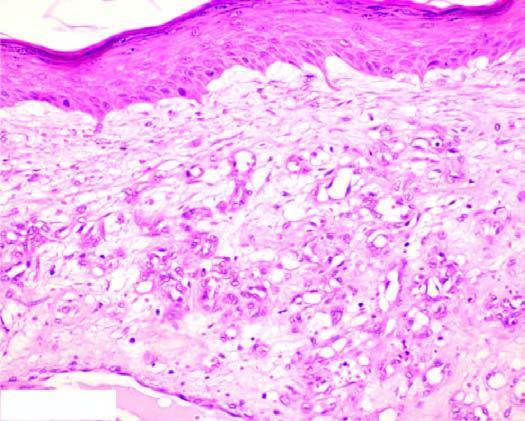what consists of scant connective tissue?
Answer the question using a single word or phrase. The intervening stroma 